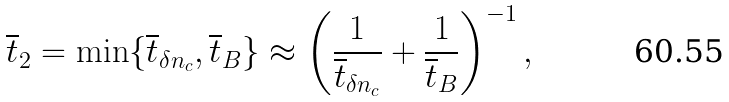<formula> <loc_0><loc_0><loc_500><loc_500>\overline { t } _ { 2 } = \min \{ \overline { t } _ { \delta n _ { c } } , \overline { t } _ { B } \} \approx \left ( \frac { 1 } { \overline { t } _ { \delta n _ { c } } } + \frac { 1 } { \overline { t } _ { B } } \right ) ^ { - 1 } ,</formula> 